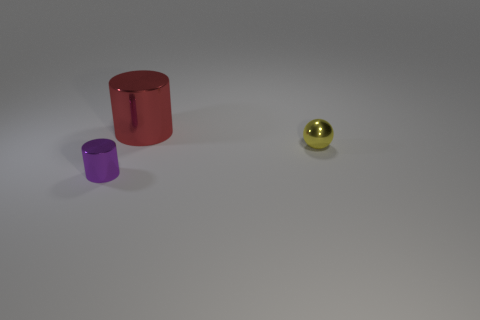Is the number of small spheres that are in front of the big metallic cylinder less than the number of big objects that are to the left of the small sphere?
Make the answer very short. No. Is the cylinder that is right of the tiny purple cylinder made of the same material as the small thing to the right of the tiny purple object?
Make the answer very short. Yes. The yellow metallic thing is what shape?
Provide a succinct answer. Sphere. Are there more red metallic objects on the left side of the big cylinder than small shiny cylinders to the left of the small purple metallic cylinder?
Ensure brevity in your answer.  No. Do the small metal thing on the left side of the small yellow metal ball and the object that is behind the tiny yellow shiny object have the same shape?
Offer a very short reply. Yes. How many other things are the same size as the red thing?
Offer a terse response. 0. The purple shiny cylinder is what size?
Your answer should be very brief. Small. Do the tiny object that is in front of the small metallic sphere and the big red cylinder have the same material?
Offer a very short reply. Yes. What color is the other small shiny thing that is the same shape as the red metal thing?
Provide a succinct answer. Purple. Do the tiny object left of the tiny ball and the large cylinder have the same color?
Your response must be concise. No. 